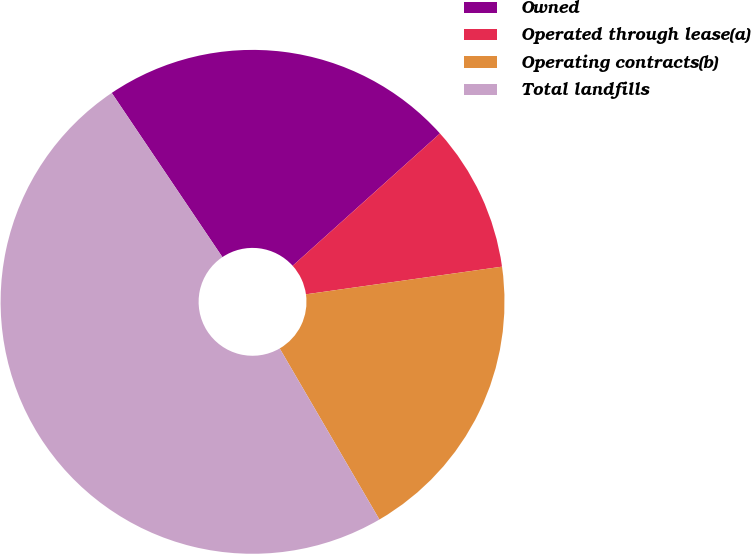<chart> <loc_0><loc_0><loc_500><loc_500><pie_chart><fcel>Owned<fcel>Operated through lease(a)<fcel>Operating contracts(b)<fcel>Total landfills<nl><fcel>22.79%<fcel>9.42%<fcel>18.83%<fcel>48.96%<nl></chart> 